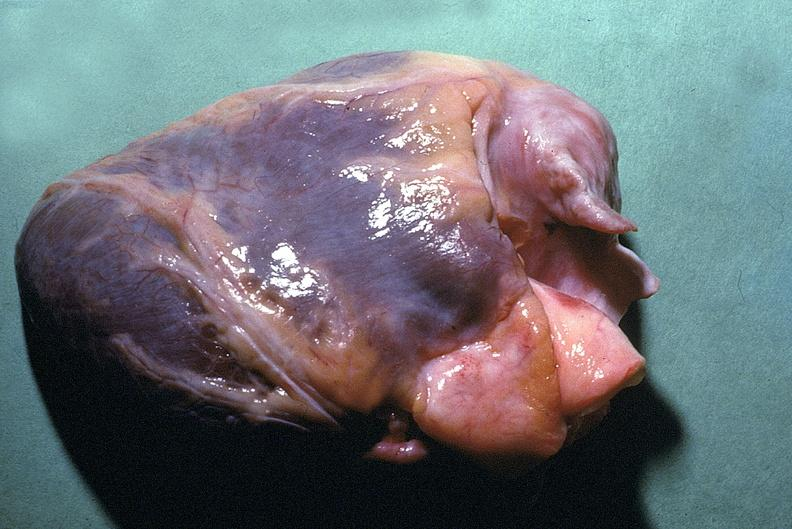does this image show normal cardiovascular?
Answer the question using a single word or phrase. Yes 